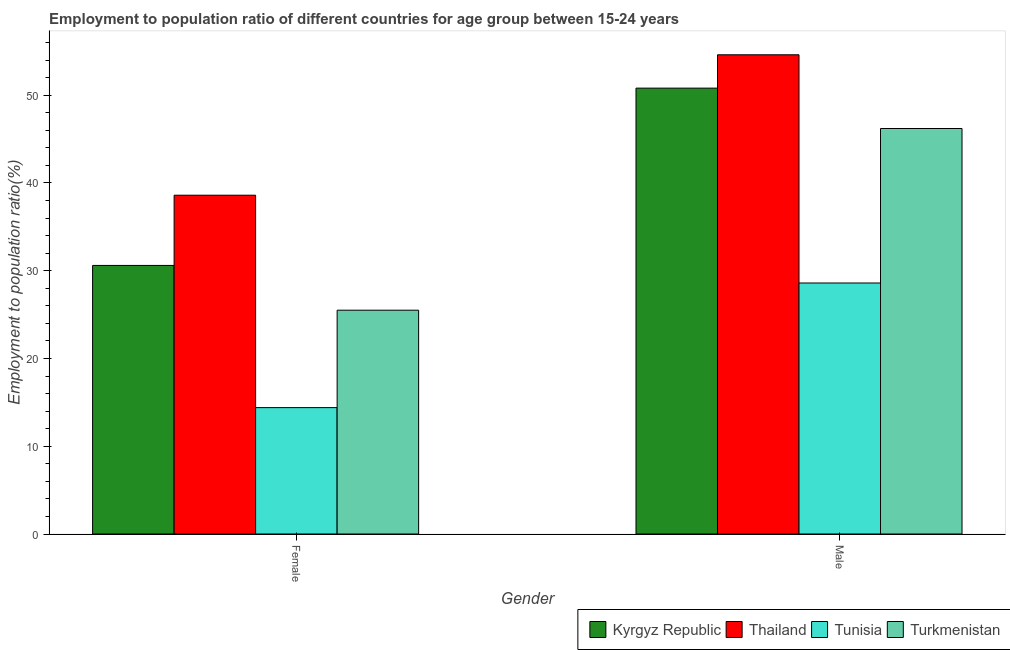How many groups of bars are there?
Ensure brevity in your answer.  2. Are the number of bars on each tick of the X-axis equal?
Offer a very short reply. Yes. Across all countries, what is the maximum employment to population ratio(female)?
Give a very brief answer. 38.6. Across all countries, what is the minimum employment to population ratio(female)?
Your response must be concise. 14.4. In which country was the employment to population ratio(male) maximum?
Keep it short and to the point. Thailand. In which country was the employment to population ratio(male) minimum?
Provide a succinct answer. Tunisia. What is the total employment to population ratio(male) in the graph?
Your response must be concise. 180.2. What is the difference between the employment to population ratio(male) in Tunisia and that in Kyrgyz Republic?
Make the answer very short. -22.2. What is the difference between the employment to population ratio(female) in Tunisia and the employment to population ratio(male) in Turkmenistan?
Make the answer very short. -31.8. What is the average employment to population ratio(female) per country?
Provide a succinct answer. 27.27. In how many countries, is the employment to population ratio(male) greater than 40 %?
Your answer should be very brief. 3. What is the ratio of the employment to population ratio(male) in Turkmenistan to that in Kyrgyz Republic?
Ensure brevity in your answer.  0.91. Is the employment to population ratio(female) in Kyrgyz Republic less than that in Thailand?
Keep it short and to the point. Yes. What does the 4th bar from the left in Female represents?
Offer a terse response. Turkmenistan. What does the 2nd bar from the right in Female represents?
Keep it short and to the point. Tunisia. How many bars are there?
Keep it short and to the point. 8. Are all the bars in the graph horizontal?
Offer a terse response. No. How many countries are there in the graph?
Provide a succinct answer. 4. What is the difference between two consecutive major ticks on the Y-axis?
Provide a succinct answer. 10. Are the values on the major ticks of Y-axis written in scientific E-notation?
Your response must be concise. No. How many legend labels are there?
Keep it short and to the point. 4. What is the title of the graph?
Offer a very short reply. Employment to population ratio of different countries for age group between 15-24 years. What is the Employment to population ratio(%) of Kyrgyz Republic in Female?
Your response must be concise. 30.6. What is the Employment to population ratio(%) in Thailand in Female?
Your answer should be compact. 38.6. What is the Employment to population ratio(%) of Tunisia in Female?
Ensure brevity in your answer.  14.4. What is the Employment to population ratio(%) of Turkmenistan in Female?
Your answer should be compact. 25.5. What is the Employment to population ratio(%) of Kyrgyz Republic in Male?
Your answer should be compact. 50.8. What is the Employment to population ratio(%) in Thailand in Male?
Provide a short and direct response. 54.6. What is the Employment to population ratio(%) of Tunisia in Male?
Give a very brief answer. 28.6. What is the Employment to population ratio(%) of Turkmenistan in Male?
Your response must be concise. 46.2. Across all Gender, what is the maximum Employment to population ratio(%) in Kyrgyz Republic?
Give a very brief answer. 50.8. Across all Gender, what is the maximum Employment to population ratio(%) in Thailand?
Offer a terse response. 54.6. Across all Gender, what is the maximum Employment to population ratio(%) of Tunisia?
Your response must be concise. 28.6. Across all Gender, what is the maximum Employment to population ratio(%) in Turkmenistan?
Give a very brief answer. 46.2. Across all Gender, what is the minimum Employment to population ratio(%) of Kyrgyz Republic?
Give a very brief answer. 30.6. Across all Gender, what is the minimum Employment to population ratio(%) in Thailand?
Keep it short and to the point. 38.6. Across all Gender, what is the minimum Employment to population ratio(%) of Tunisia?
Make the answer very short. 14.4. Across all Gender, what is the minimum Employment to population ratio(%) in Turkmenistan?
Your response must be concise. 25.5. What is the total Employment to population ratio(%) in Kyrgyz Republic in the graph?
Your answer should be compact. 81.4. What is the total Employment to population ratio(%) in Thailand in the graph?
Give a very brief answer. 93.2. What is the total Employment to population ratio(%) in Turkmenistan in the graph?
Provide a succinct answer. 71.7. What is the difference between the Employment to population ratio(%) in Kyrgyz Republic in Female and that in Male?
Your answer should be very brief. -20.2. What is the difference between the Employment to population ratio(%) in Thailand in Female and that in Male?
Provide a short and direct response. -16. What is the difference between the Employment to population ratio(%) in Turkmenistan in Female and that in Male?
Provide a succinct answer. -20.7. What is the difference between the Employment to population ratio(%) of Kyrgyz Republic in Female and the Employment to population ratio(%) of Turkmenistan in Male?
Make the answer very short. -15.6. What is the difference between the Employment to population ratio(%) of Thailand in Female and the Employment to population ratio(%) of Tunisia in Male?
Give a very brief answer. 10. What is the difference between the Employment to population ratio(%) in Tunisia in Female and the Employment to population ratio(%) in Turkmenistan in Male?
Your answer should be compact. -31.8. What is the average Employment to population ratio(%) in Kyrgyz Republic per Gender?
Your answer should be compact. 40.7. What is the average Employment to population ratio(%) in Thailand per Gender?
Your answer should be compact. 46.6. What is the average Employment to population ratio(%) in Turkmenistan per Gender?
Provide a succinct answer. 35.85. What is the difference between the Employment to population ratio(%) in Kyrgyz Republic and Employment to population ratio(%) in Turkmenistan in Female?
Your answer should be very brief. 5.1. What is the difference between the Employment to population ratio(%) in Thailand and Employment to population ratio(%) in Tunisia in Female?
Your answer should be compact. 24.2. What is the difference between the Employment to population ratio(%) in Tunisia and Employment to population ratio(%) in Turkmenistan in Female?
Your answer should be compact. -11.1. What is the difference between the Employment to population ratio(%) in Kyrgyz Republic and Employment to population ratio(%) in Tunisia in Male?
Keep it short and to the point. 22.2. What is the difference between the Employment to population ratio(%) of Thailand and Employment to population ratio(%) of Tunisia in Male?
Give a very brief answer. 26. What is the difference between the Employment to population ratio(%) in Thailand and Employment to population ratio(%) in Turkmenistan in Male?
Keep it short and to the point. 8.4. What is the difference between the Employment to population ratio(%) in Tunisia and Employment to population ratio(%) in Turkmenistan in Male?
Offer a terse response. -17.6. What is the ratio of the Employment to population ratio(%) in Kyrgyz Republic in Female to that in Male?
Your response must be concise. 0.6. What is the ratio of the Employment to population ratio(%) in Thailand in Female to that in Male?
Provide a short and direct response. 0.71. What is the ratio of the Employment to population ratio(%) in Tunisia in Female to that in Male?
Keep it short and to the point. 0.5. What is the ratio of the Employment to population ratio(%) in Turkmenistan in Female to that in Male?
Keep it short and to the point. 0.55. What is the difference between the highest and the second highest Employment to population ratio(%) in Kyrgyz Republic?
Your answer should be compact. 20.2. What is the difference between the highest and the second highest Employment to population ratio(%) in Thailand?
Your answer should be compact. 16. What is the difference between the highest and the second highest Employment to population ratio(%) in Tunisia?
Make the answer very short. 14.2. What is the difference between the highest and the second highest Employment to population ratio(%) of Turkmenistan?
Give a very brief answer. 20.7. What is the difference between the highest and the lowest Employment to population ratio(%) in Kyrgyz Republic?
Give a very brief answer. 20.2. What is the difference between the highest and the lowest Employment to population ratio(%) of Thailand?
Offer a terse response. 16. What is the difference between the highest and the lowest Employment to population ratio(%) of Tunisia?
Your answer should be very brief. 14.2. What is the difference between the highest and the lowest Employment to population ratio(%) of Turkmenistan?
Your answer should be compact. 20.7. 